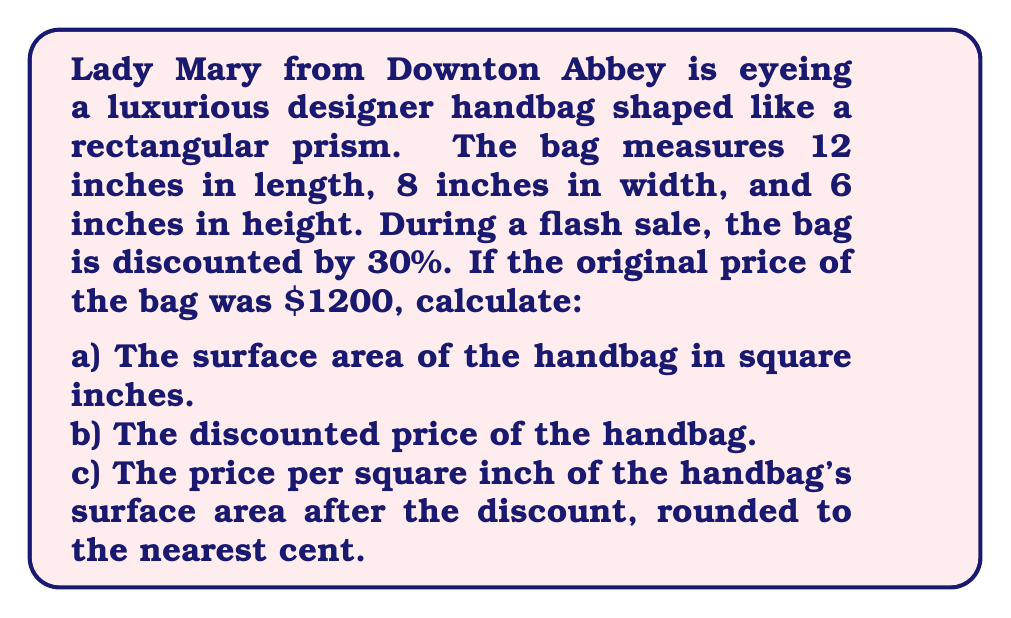Can you solve this math problem? Let's approach this problem step by step:

a) To calculate the surface area of the rectangular prism-shaped handbag:

The surface area of a rectangular prism is given by the formula:
$$SA = 2(lw + lh + wh)$$
Where $l$ is length, $w$ is width, and $h$ is height.

Substituting the given dimensions:
$$SA = 2((12 \times 8) + (12 \times 6) + (8 \times 6))$$
$$SA = 2(96 + 72 + 48)$$
$$SA = 2(216)$$
$$SA = 432\text{ square inches}$$

b) To calculate the discounted price:

Original price: $1200
Discount: 30% = 0.30

Discount amount: $$1200 \times 0.30 = $360$$

Discounted price: $$1200 - 360 = $840$$

c) To calculate the price per square inch after discount:

Price per square inch = Discounted price ÷ Surface area
$$\frac{$840}{432\text{ sq in}} \approx $1.94\text{ per square inch}$$
Answer: a) The surface area of the handbag is 432 square inches.
b) The discounted price of the handbag is $840.
c) The price per square inch of the handbag's surface area after the discount is $1.94 per square inch. 